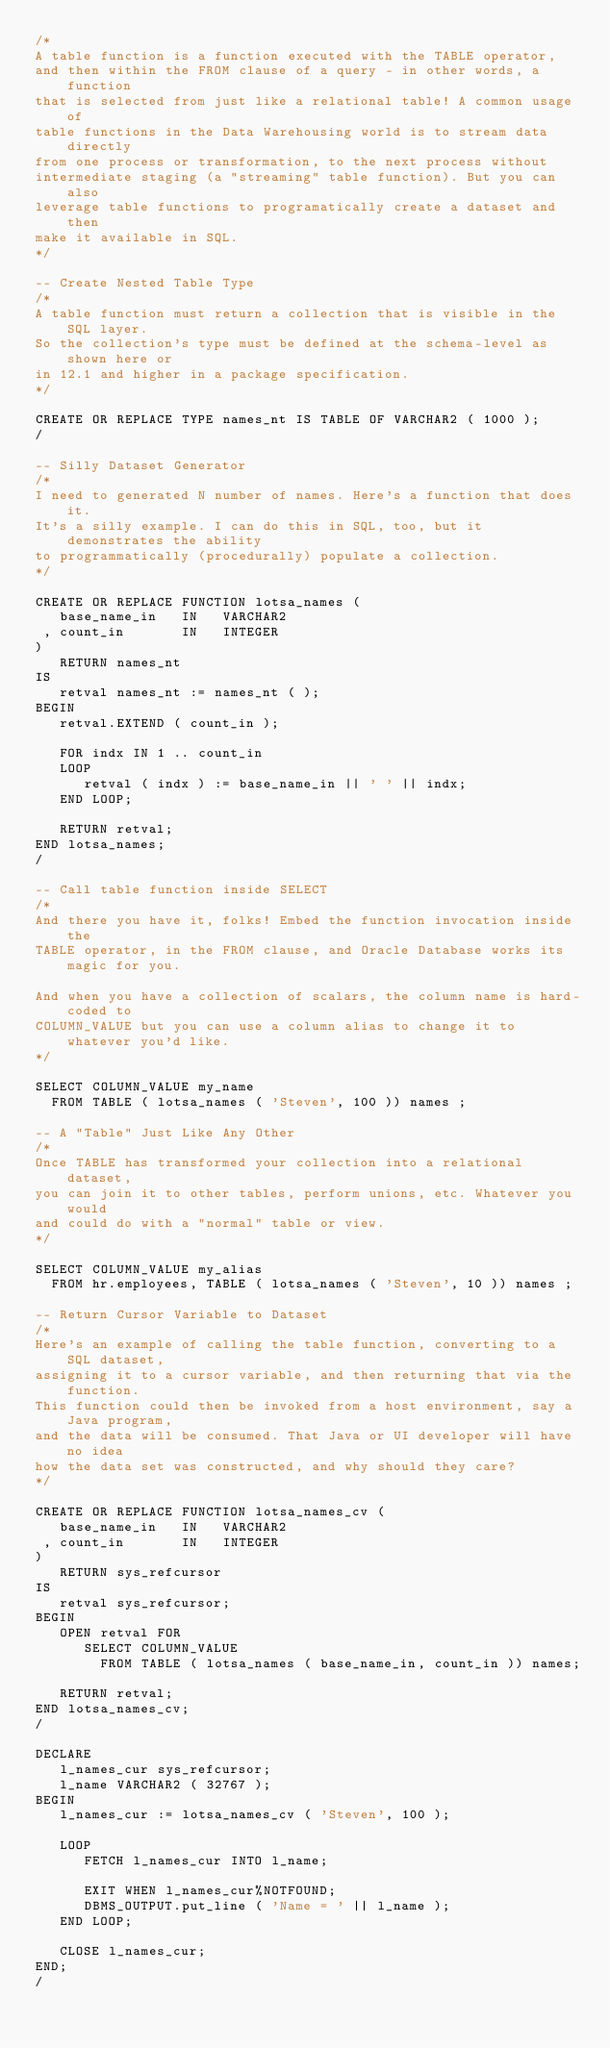Convert code to text. <code><loc_0><loc_0><loc_500><loc_500><_SQL_>/*
A table function is a function executed with the TABLE operator, 
and then within the FROM clause of a query - in other words, a function 
that is selected from just like a relational table! A common usage of 
table functions in the Data Warehousing world is to stream data directly 
from one process or transformation, to the next process without 
intermediate staging (a "streaming" table function). But you can also 
leverage table functions to programatically create a dataset and then 
make it available in SQL.
*/

-- Create Nested Table Type
/*
A table function must return a collection that is visible in the SQL layer. 
So the collection's type must be defined at the schema-level as shown here or 
in 12.1 and higher in a package specification.
*/

CREATE OR REPLACE TYPE names_nt IS TABLE OF VARCHAR2 ( 1000 ); 
/

-- Silly Dataset Generator
/*
I need to generated N number of names. Here's a function that does it. 
It's a silly example. I can do this in SQL, too, but it demonstrates the ability 
to programmatically (procedurally) populate a collection.
*/

CREATE OR REPLACE FUNCTION lotsa_names (  
   base_name_in   IN   VARCHAR2  
 , count_in       IN   INTEGER  
)  
   RETURN names_nt  
IS  
   retval names_nt := names_nt ( );  
BEGIN  
   retval.EXTEND ( count_in );  
  
   FOR indx IN 1 .. count_in  
   LOOP  
      retval ( indx ) := base_name_in || ' ' || indx;  
   END LOOP;  
  
   RETURN retval;  
END lotsa_names; 
/

-- Call table function inside SELECT  
/*
And there you have it, folks! Embed the function invocation inside the 
TABLE operator, in the FROM clause, and Oracle Database works its magic for you. 

And when you have a collection of scalars, the column name is hard-coded to 
COLUMN_VALUE but you can use a column alias to change it to whatever you'd like.
*/

SELECT COLUMN_VALUE my_name 
  FROM TABLE ( lotsa_names ( 'Steven', 100 )) names ;

-- A "Table" Just Like Any Other
/*
Once TABLE has transformed your collection into a relational dataset, 
you can join it to other tables, perform unions, etc. Whatever you would 
and could do with a "normal" table or view.
*/

SELECT COLUMN_VALUE my_alias  
  FROM hr.employees, TABLE ( lotsa_names ( 'Steven', 10 )) names ;

-- Return Cursor Variable to Dataset
/*
Here's an example of calling the table function, converting to a SQL dataset, 
assigning it to a cursor variable, and then returning that via the function. 
This function could then be invoked from a host environment, say a Java program, 
and the data will be consumed. That Java or UI developer will have no idea 
how the data set was constructed, and why should they care?
*/

CREATE OR REPLACE FUNCTION lotsa_names_cv (  
   base_name_in   IN   VARCHAR2  
 , count_in       IN   INTEGER  
)  
   RETURN sys_refcursor  
IS  
   retval sys_refcursor;  
BEGIN  
   OPEN retval FOR  
      SELECT COLUMN_VALUE  
        FROM TABLE ( lotsa_names ( base_name_in, count_in )) names;  
  
   RETURN retval;  
END lotsa_names_cv; 
/

DECLARE 
   l_names_cur sys_refcursor; 
   l_name VARCHAR2 ( 32767 ); 
BEGIN 
   l_names_cur := lotsa_names_cv ( 'Steven', 100 ); 
 
   LOOP 
      FETCH l_names_cur INTO l_name; 
 
      EXIT WHEN l_names_cur%NOTFOUND; 
      DBMS_OUTPUT.put_line ( 'Name = ' || l_name ); 
   END LOOP; 
 
   CLOSE l_names_cur; 
END; 
/

</code> 